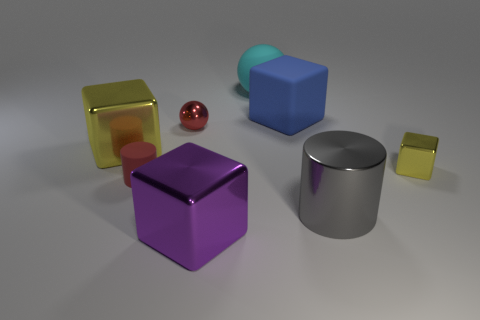The cyan object is what shape?
Provide a short and direct response. Sphere. There is a sphere that is the same color as the small matte cylinder; what is its size?
Your answer should be very brief. Small. What is the size of the metallic cube that is to the right of the big block that is behind the small red metal sphere?
Offer a terse response. Small. There is a yellow cube that is on the right side of the matte block; how big is it?
Ensure brevity in your answer.  Small. Is the number of big gray cylinders right of the big gray object less than the number of tiny red metal spheres that are behind the tiny cube?
Give a very brief answer. Yes. What is the color of the large rubber sphere?
Provide a short and direct response. Cyan. Is there a matte block of the same color as the matte cylinder?
Provide a succinct answer. No. There is a shiny object behind the yellow block that is on the left side of the large metal thing that is right of the large blue cube; what is its shape?
Your answer should be compact. Sphere. There is a small red object behind the matte cylinder; what is its material?
Your response must be concise. Metal. What size is the yellow cube that is to the left of the big block that is in front of the yellow object to the left of the purple metal cube?
Provide a short and direct response. Large. 